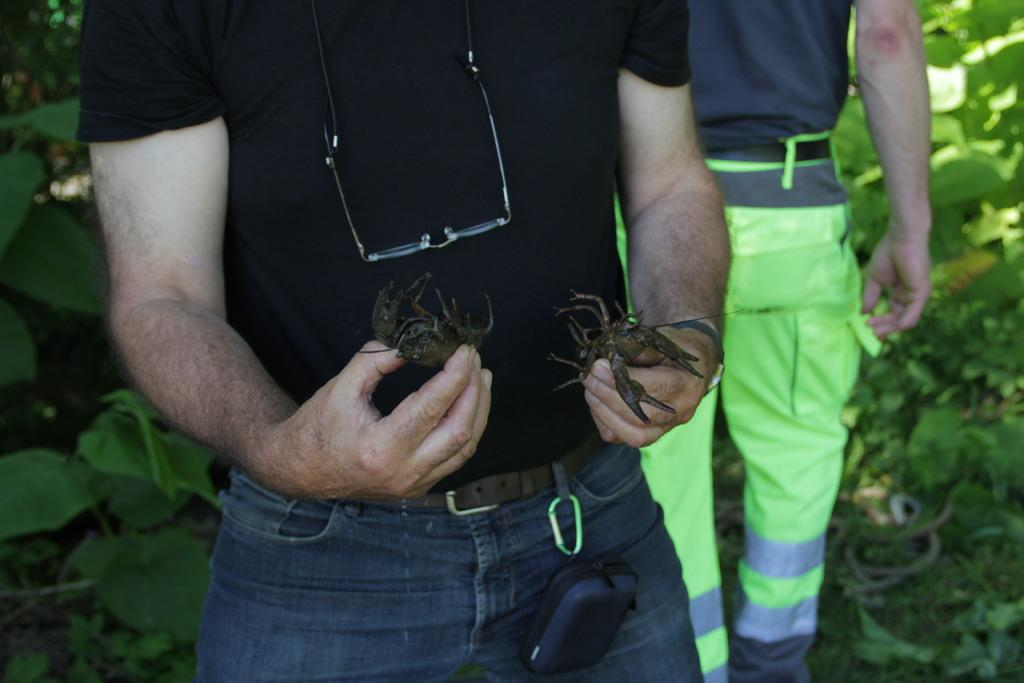What is the person in the image holding? The person in the image is holding crabs. What can be seen in the background of the image? Green leaves are visible in the background of the image. Can you describe any other people in the image? The lower body of another person is present in the background of the image. What type of instrument is the person playing in the image? There is no instrument present in the image; the person is holding crabs. 